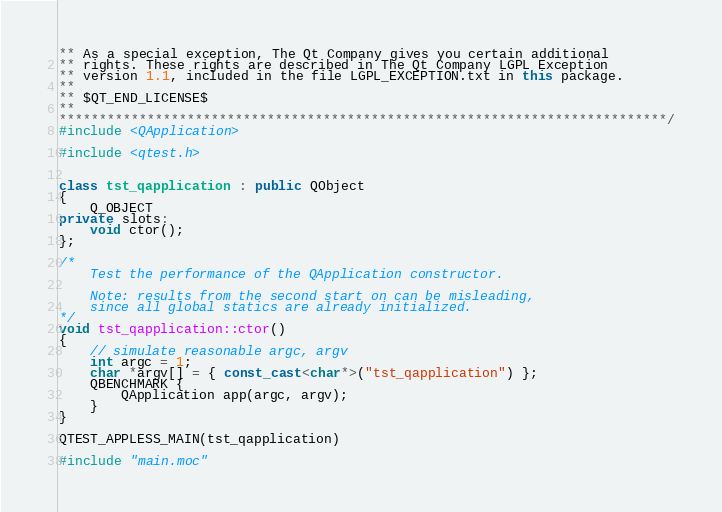<code> <loc_0><loc_0><loc_500><loc_500><_C++_>** As a special exception, The Qt Company gives you certain additional
** rights. These rights are described in The Qt Company LGPL Exception
** version 1.1, included in the file LGPL_EXCEPTION.txt in this package.
**
** $QT_END_LICENSE$
**
****************************************************************************/
#include <QApplication>

#include <qtest.h>


class tst_qapplication : public QObject
{
    Q_OBJECT
private slots:
    void ctor();
};

/*
    Test the performance of the QApplication constructor.

    Note: results from the second start on can be misleading,
    since all global statics are already initialized.
*/
void tst_qapplication::ctor()
{
    // simulate reasonable argc, argv
    int argc = 1;
    char *argv[] = { const_cast<char*>("tst_qapplication") };
    QBENCHMARK {
        QApplication app(argc, argv);
    }
}

QTEST_APPLESS_MAIN(tst_qapplication)

#include "main.moc"
</code> 